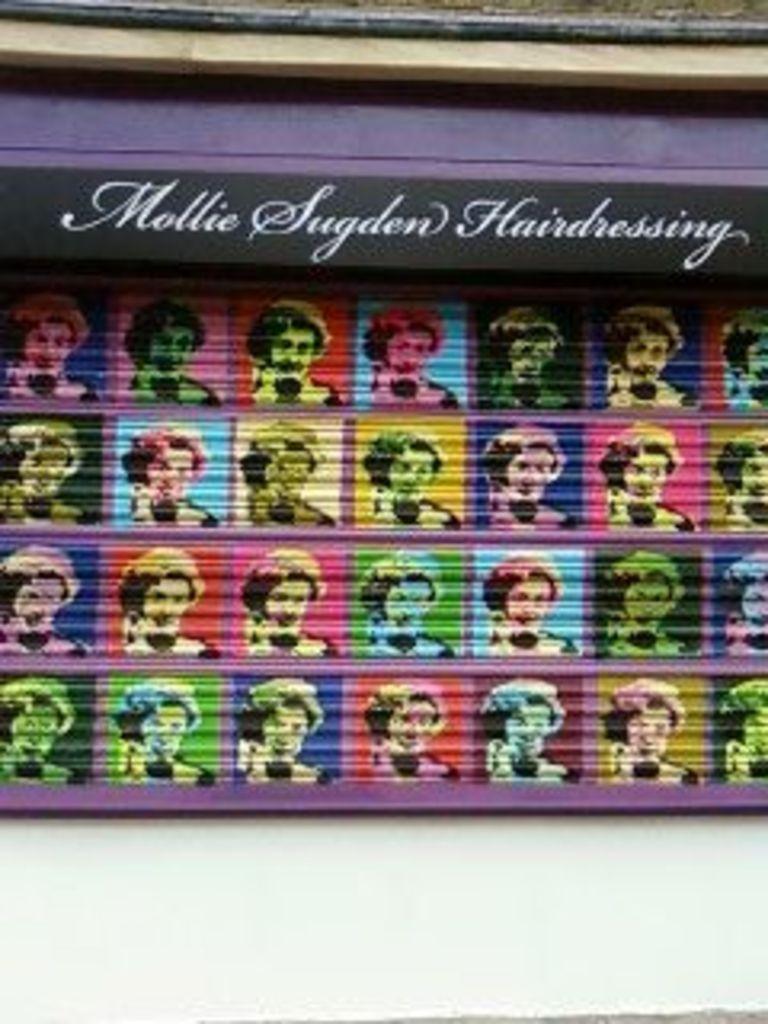Could you give a brief overview of what you see in this image? In this image we can see a wall. On the wall we can see some text and group of images of a person. 